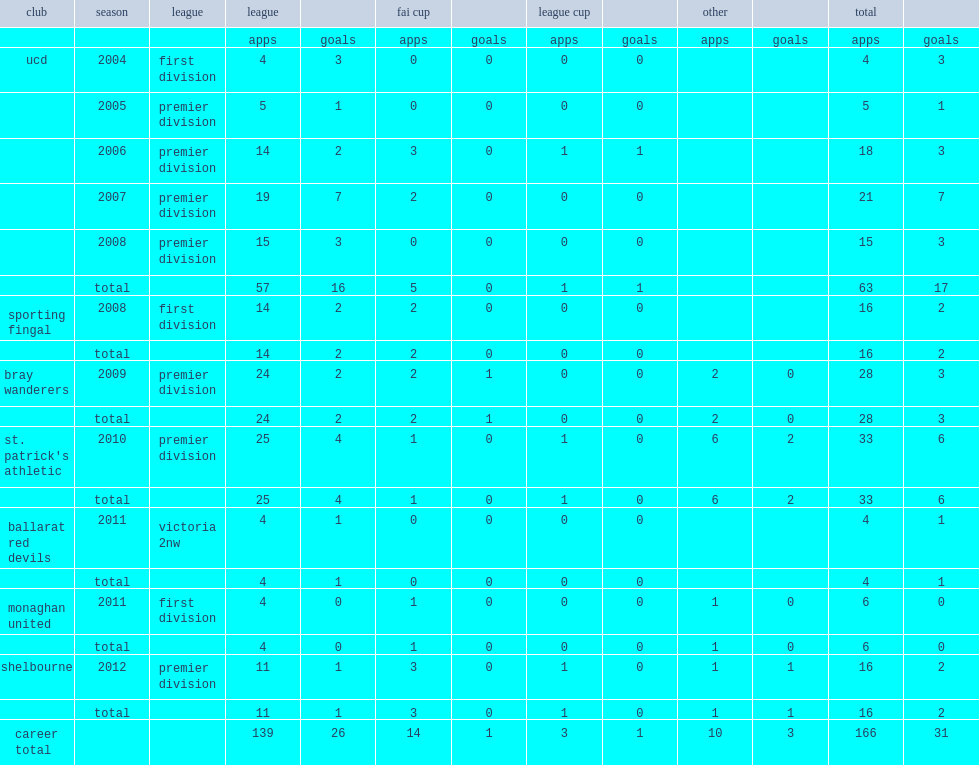I'm looking to parse the entire table for insights. Could you assist me with that? {'header': ['club', 'season', 'league', 'league', '', 'fai cup', '', 'league cup', '', 'other', '', 'total', ''], 'rows': [['', '', '', 'apps', 'goals', 'apps', 'goals', 'apps', 'goals', 'apps', 'goals', 'apps', 'goals'], ['ucd', '2004', 'first division', '4', '3', '0', '0', '0', '0', '', '', '4', '3'], ['', '2005', 'premier division', '5', '1', '0', '0', '0', '0', '', '', '5', '1'], ['', '2006', 'premier division', '14', '2', '3', '0', '1', '1', '', '', '18', '3'], ['', '2007', 'premier division', '19', '7', '2', '0', '0', '0', '', '', '21', '7'], ['', '2008', 'premier division', '15', '3', '0', '0', '0', '0', '', '', '15', '3'], ['', 'total', '', '57', '16', '5', '0', '1', '1', '', '', '63', '17'], ['sporting fingal', '2008', 'first division', '14', '2', '2', '0', '0', '0', '', '', '16', '2'], ['', 'total', '', '14', '2', '2', '0', '0', '0', '', '', '16', '2'], ['bray wanderers', '2009', 'premier division', '24', '2', '2', '1', '0', '0', '2', '0', '28', '3'], ['', 'total', '', '24', '2', '2', '1', '0', '0', '2', '0', '28', '3'], ["st. patrick's athletic", '2010', 'premier division', '25', '4', '1', '0', '1', '0', '6', '2', '33', '6'], ['', 'total', '', '25', '4', '1', '0', '1', '0', '6', '2', '33', '6'], ['ballarat red devils', '2011', 'victoria 2nw', '4', '1', '0', '0', '0', '0', '', '', '4', '1'], ['', 'total', '', '4', '1', '0', '0', '0', '0', '', '', '4', '1'], ['monaghan united', '2011', 'first division', '4', '0', '1', '0', '0', '0', '1', '0', '6', '0'], ['', 'total', '', '4', '0', '1', '0', '0', '0', '1', '0', '6', '0'], ['shelbourne', '2012', 'premier division', '11', '1', '3', '0', '1', '0', '1', '1', '16', '2'], ['', 'total', '', '11', '1', '3', '0', '1', '0', '1', '1', '16', '2'], ['career total', '', '', '139', '26', '14', '1', '3', '1', '10', '3', '166', '31']]} In 2012, which league did byrne join club shelbourne? Premier division. 